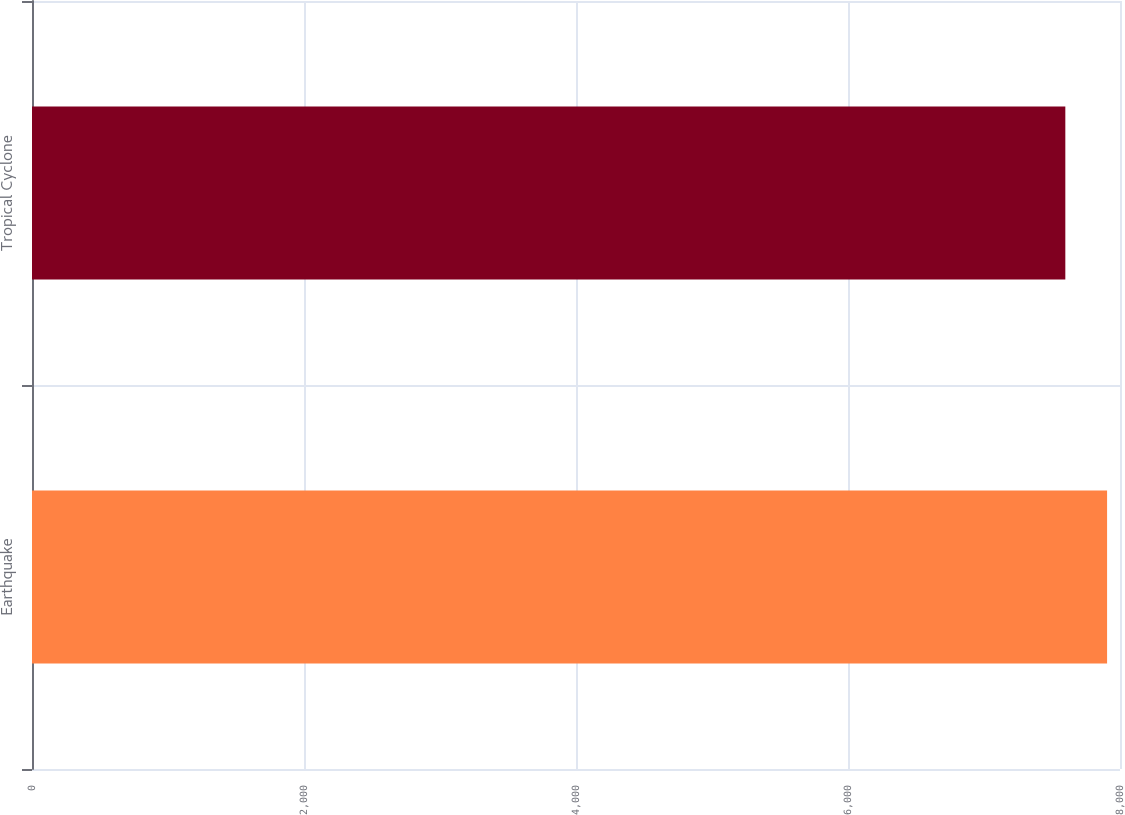<chart> <loc_0><loc_0><loc_500><loc_500><bar_chart><fcel>Earthquake<fcel>Tropical Cyclone<nl><fcel>7905<fcel>7598<nl></chart> 